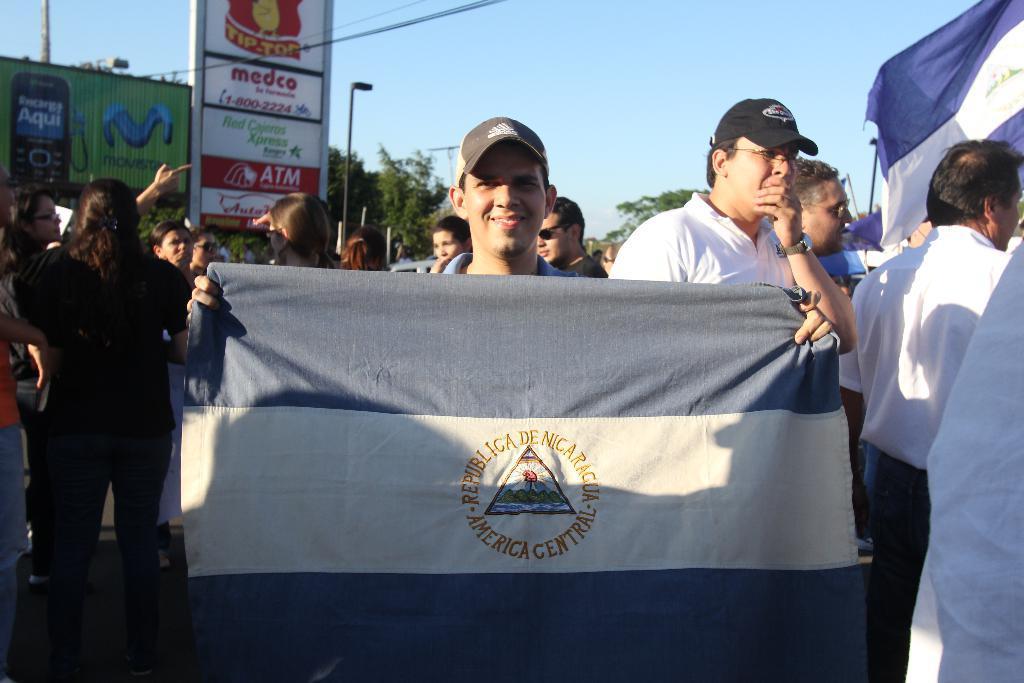Could you give a brief overview of what you see in this image? In this picture I can see a man standing in front and holding a flag and I see something is written on it and I see that he is smiling. In the middle of this picture I can see number of people standing and I can see few more flags. In the background I can see the boards, on which there is something written and I can see few poles, trees and the sky. 